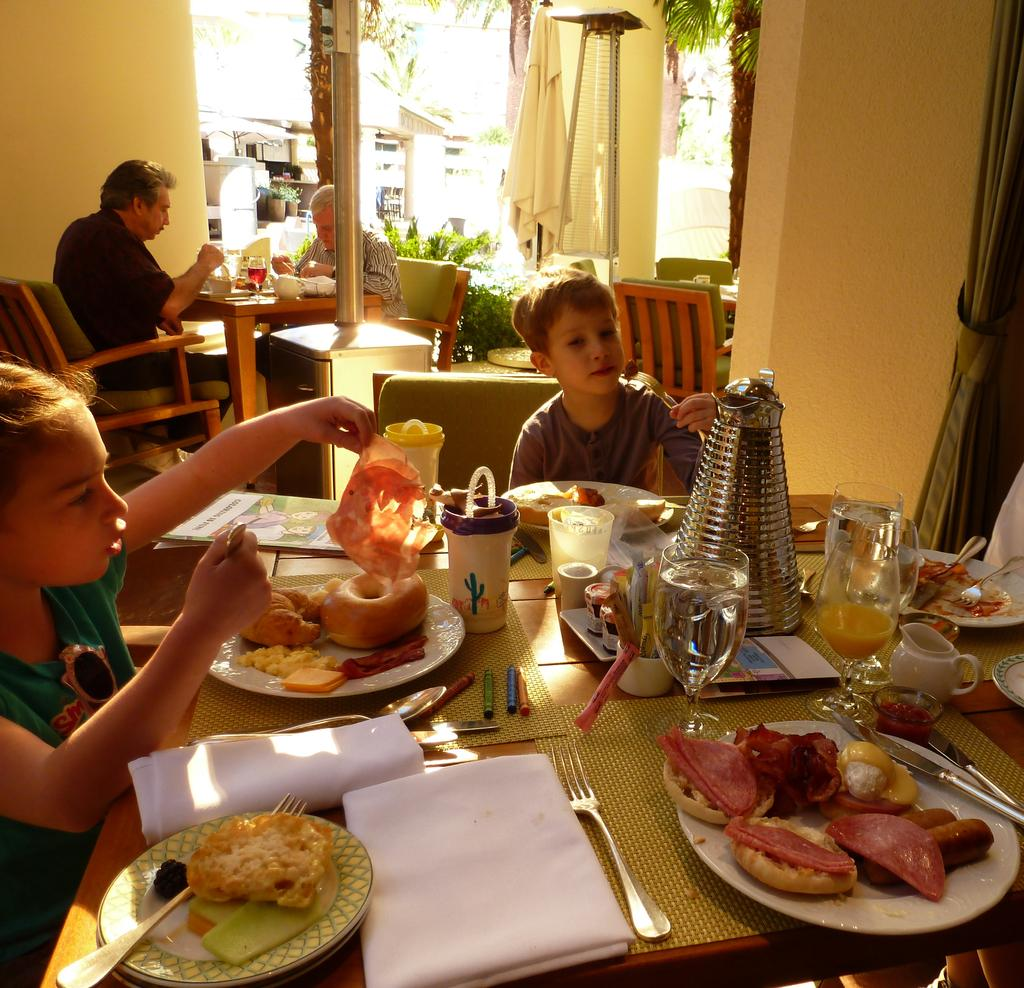What is the main subject of the image? The main subject of the image is a group of people standing near a monument. Can you describe the monument? The monument has a statue on top. What can be seen in the background of the image? There is a park in the background. What type of meeting is taking place near the monument in the image? There is no indication of a meeting in the image; it simply shows a group of people standing near a monument. How many bikes are visible in the image? There are no bikes present in the image. 